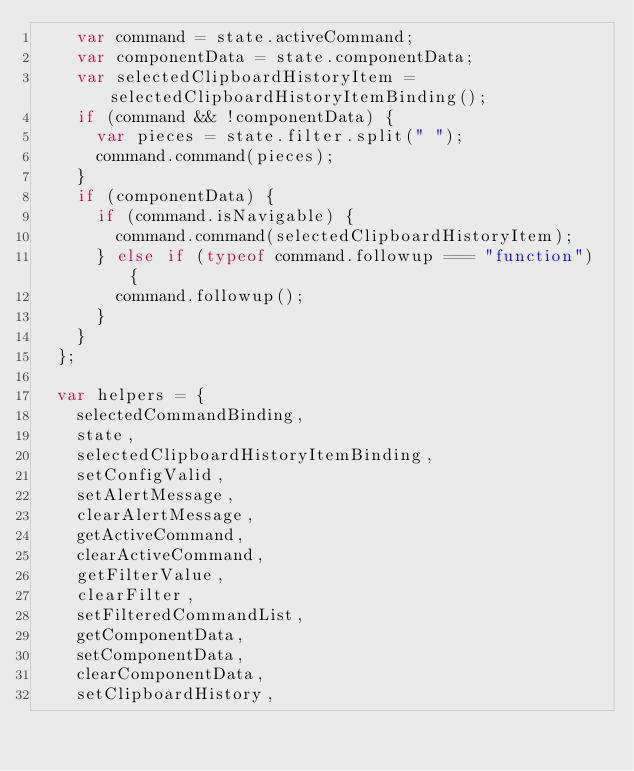<code> <loc_0><loc_0><loc_500><loc_500><_JavaScript_>    var command = state.activeCommand;
    var componentData = state.componentData;
    var selectedClipboardHistoryItem = selectedClipboardHistoryItemBinding();
    if (command && !componentData) {
      var pieces = state.filter.split(" ");
      command.command(pieces);
    }
    if (componentData) {
      if (command.isNavigable) {
        command.command(selectedClipboardHistoryItem);
      } else if (typeof command.followup === "function") {
        command.followup();
      }
    }
  };

  var helpers = {
    selectedCommandBinding,
    state,
    selectedClipboardHistoryItemBinding,
    setConfigValid,
    setAlertMessage,
    clearAlertMessage,
    getActiveCommand,
    clearActiveCommand,
    getFilterValue,
    clearFilter,
    setFilteredCommandList,
    getComponentData,
    setComponentData,
    clearComponentData,
    setClipboardHistory,</code> 